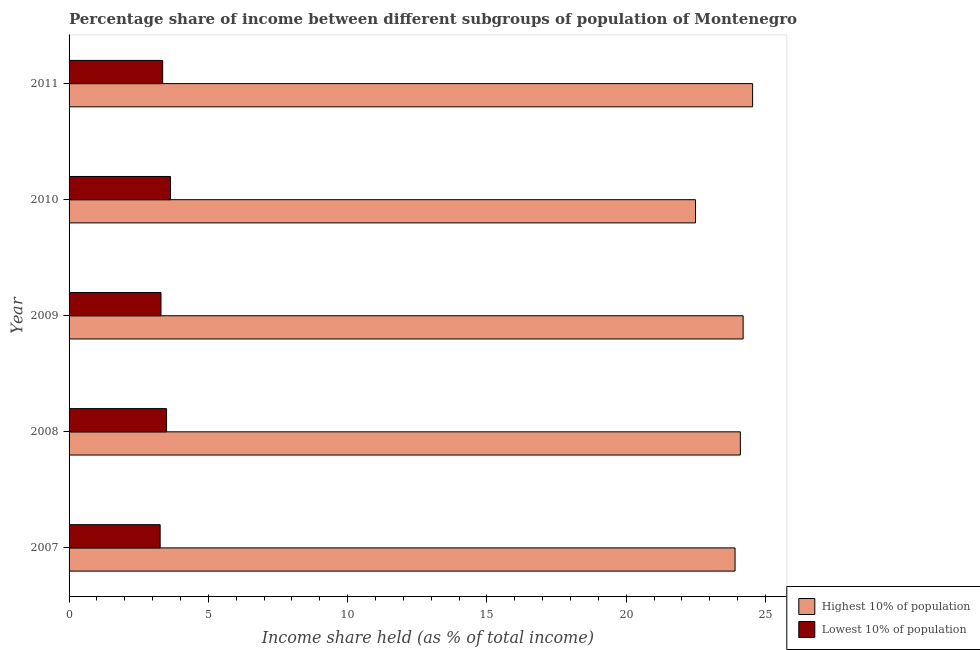How many groups of bars are there?
Provide a short and direct response. 5. Are the number of bars per tick equal to the number of legend labels?
Provide a succinct answer. Yes. Are the number of bars on each tick of the Y-axis equal?
Your answer should be very brief. Yes. How many bars are there on the 2nd tick from the top?
Keep it short and to the point. 2. In how many cases, is the number of bars for a given year not equal to the number of legend labels?
Give a very brief answer. 0. What is the income share held by highest 10% of the population in 2009?
Offer a terse response. 24.2. Across all years, what is the maximum income share held by lowest 10% of the population?
Make the answer very short. 3.64. Across all years, what is the minimum income share held by highest 10% of the population?
Ensure brevity in your answer.  22.49. In which year was the income share held by lowest 10% of the population maximum?
Provide a succinct answer. 2010. In which year was the income share held by highest 10% of the population minimum?
Your answer should be very brief. 2010. What is the total income share held by lowest 10% of the population in the graph?
Offer a terse response. 17.07. What is the difference between the income share held by highest 10% of the population in 2007 and that in 2011?
Your answer should be compact. -0.63. What is the difference between the income share held by highest 10% of the population in 2009 and the income share held by lowest 10% of the population in 2008?
Offer a terse response. 20.7. What is the average income share held by highest 10% of the population per year?
Provide a short and direct response. 23.85. In the year 2011, what is the difference between the income share held by highest 10% of the population and income share held by lowest 10% of the population?
Offer a terse response. 21.18. What is the ratio of the income share held by highest 10% of the population in 2007 to that in 2011?
Provide a short and direct response. 0.97. Is the difference between the income share held by highest 10% of the population in 2007 and 2011 greater than the difference between the income share held by lowest 10% of the population in 2007 and 2011?
Provide a short and direct response. No. What is the difference between the highest and the second highest income share held by highest 10% of the population?
Give a very brief answer. 0.34. What is the difference between the highest and the lowest income share held by lowest 10% of the population?
Provide a succinct answer. 0.37. In how many years, is the income share held by lowest 10% of the population greater than the average income share held by lowest 10% of the population taken over all years?
Provide a short and direct response. 2. Is the sum of the income share held by lowest 10% of the population in 2008 and 2011 greater than the maximum income share held by highest 10% of the population across all years?
Provide a succinct answer. No. What does the 2nd bar from the top in 2010 represents?
Your answer should be compact. Highest 10% of population. What does the 1st bar from the bottom in 2010 represents?
Make the answer very short. Highest 10% of population. How many bars are there?
Make the answer very short. 10. Are the values on the major ticks of X-axis written in scientific E-notation?
Your answer should be very brief. No. How many legend labels are there?
Keep it short and to the point. 2. What is the title of the graph?
Give a very brief answer. Percentage share of income between different subgroups of population of Montenegro. Does "Imports" appear as one of the legend labels in the graph?
Provide a succinct answer. No. What is the label or title of the X-axis?
Provide a succinct answer. Income share held (as % of total income). What is the label or title of the Y-axis?
Provide a short and direct response. Year. What is the Income share held (as % of total income) of Highest 10% of population in 2007?
Your response must be concise. 23.91. What is the Income share held (as % of total income) of Lowest 10% of population in 2007?
Your response must be concise. 3.27. What is the Income share held (as % of total income) of Highest 10% of population in 2008?
Offer a terse response. 24.1. What is the Income share held (as % of total income) of Highest 10% of population in 2009?
Offer a terse response. 24.2. What is the Income share held (as % of total income) in Highest 10% of population in 2010?
Provide a succinct answer. 22.49. What is the Income share held (as % of total income) in Lowest 10% of population in 2010?
Provide a short and direct response. 3.64. What is the Income share held (as % of total income) of Highest 10% of population in 2011?
Your response must be concise. 24.54. What is the Income share held (as % of total income) of Lowest 10% of population in 2011?
Ensure brevity in your answer.  3.36. Across all years, what is the maximum Income share held (as % of total income) of Highest 10% of population?
Keep it short and to the point. 24.54. Across all years, what is the maximum Income share held (as % of total income) of Lowest 10% of population?
Your answer should be compact. 3.64. Across all years, what is the minimum Income share held (as % of total income) in Highest 10% of population?
Your answer should be compact. 22.49. Across all years, what is the minimum Income share held (as % of total income) in Lowest 10% of population?
Make the answer very short. 3.27. What is the total Income share held (as % of total income) in Highest 10% of population in the graph?
Make the answer very short. 119.24. What is the total Income share held (as % of total income) of Lowest 10% of population in the graph?
Your response must be concise. 17.07. What is the difference between the Income share held (as % of total income) in Highest 10% of population in 2007 and that in 2008?
Offer a terse response. -0.19. What is the difference between the Income share held (as % of total income) of Lowest 10% of population in 2007 and that in 2008?
Offer a very short reply. -0.23. What is the difference between the Income share held (as % of total income) in Highest 10% of population in 2007 and that in 2009?
Your answer should be compact. -0.29. What is the difference between the Income share held (as % of total income) in Lowest 10% of population in 2007 and that in 2009?
Your response must be concise. -0.03. What is the difference between the Income share held (as % of total income) of Highest 10% of population in 2007 and that in 2010?
Make the answer very short. 1.42. What is the difference between the Income share held (as % of total income) in Lowest 10% of population in 2007 and that in 2010?
Make the answer very short. -0.37. What is the difference between the Income share held (as % of total income) in Highest 10% of population in 2007 and that in 2011?
Your response must be concise. -0.63. What is the difference between the Income share held (as % of total income) in Lowest 10% of population in 2007 and that in 2011?
Your answer should be compact. -0.09. What is the difference between the Income share held (as % of total income) in Highest 10% of population in 2008 and that in 2009?
Make the answer very short. -0.1. What is the difference between the Income share held (as % of total income) in Lowest 10% of population in 2008 and that in 2009?
Offer a terse response. 0.2. What is the difference between the Income share held (as % of total income) of Highest 10% of population in 2008 and that in 2010?
Provide a succinct answer. 1.61. What is the difference between the Income share held (as % of total income) in Lowest 10% of population in 2008 and that in 2010?
Provide a succinct answer. -0.14. What is the difference between the Income share held (as % of total income) in Highest 10% of population in 2008 and that in 2011?
Your response must be concise. -0.44. What is the difference between the Income share held (as % of total income) of Lowest 10% of population in 2008 and that in 2011?
Give a very brief answer. 0.14. What is the difference between the Income share held (as % of total income) in Highest 10% of population in 2009 and that in 2010?
Offer a very short reply. 1.71. What is the difference between the Income share held (as % of total income) in Lowest 10% of population in 2009 and that in 2010?
Ensure brevity in your answer.  -0.34. What is the difference between the Income share held (as % of total income) in Highest 10% of population in 2009 and that in 2011?
Offer a very short reply. -0.34. What is the difference between the Income share held (as % of total income) in Lowest 10% of population in 2009 and that in 2011?
Make the answer very short. -0.06. What is the difference between the Income share held (as % of total income) of Highest 10% of population in 2010 and that in 2011?
Keep it short and to the point. -2.05. What is the difference between the Income share held (as % of total income) of Lowest 10% of population in 2010 and that in 2011?
Your answer should be very brief. 0.28. What is the difference between the Income share held (as % of total income) of Highest 10% of population in 2007 and the Income share held (as % of total income) of Lowest 10% of population in 2008?
Your response must be concise. 20.41. What is the difference between the Income share held (as % of total income) of Highest 10% of population in 2007 and the Income share held (as % of total income) of Lowest 10% of population in 2009?
Keep it short and to the point. 20.61. What is the difference between the Income share held (as % of total income) in Highest 10% of population in 2007 and the Income share held (as % of total income) in Lowest 10% of population in 2010?
Keep it short and to the point. 20.27. What is the difference between the Income share held (as % of total income) of Highest 10% of population in 2007 and the Income share held (as % of total income) of Lowest 10% of population in 2011?
Offer a very short reply. 20.55. What is the difference between the Income share held (as % of total income) in Highest 10% of population in 2008 and the Income share held (as % of total income) in Lowest 10% of population in 2009?
Offer a terse response. 20.8. What is the difference between the Income share held (as % of total income) of Highest 10% of population in 2008 and the Income share held (as % of total income) of Lowest 10% of population in 2010?
Give a very brief answer. 20.46. What is the difference between the Income share held (as % of total income) of Highest 10% of population in 2008 and the Income share held (as % of total income) of Lowest 10% of population in 2011?
Offer a terse response. 20.74. What is the difference between the Income share held (as % of total income) of Highest 10% of population in 2009 and the Income share held (as % of total income) of Lowest 10% of population in 2010?
Your answer should be very brief. 20.56. What is the difference between the Income share held (as % of total income) in Highest 10% of population in 2009 and the Income share held (as % of total income) in Lowest 10% of population in 2011?
Ensure brevity in your answer.  20.84. What is the difference between the Income share held (as % of total income) in Highest 10% of population in 2010 and the Income share held (as % of total income) in Lowest 10% of population in 2011?
Your response must be concise. 19.13. What is the average Income share held (as % of total income) of Highest 10% of population per year?
Provide a succinct answer. 23.85. What is the average Income share held (as % of total income) in Lowest 10% of population per year?
Offer a very short reply. 3.41. In the year 2007, what is the difference between the Income share held (as % of total income) in Highest 10% of population and Income share held (as % of total income) in Lowest 10% of population?
Provide a short and direct response. 20.64. In the year 2008, what is the difference between the Income share held (as % of total income) in Highest 10% of population and Income share held (as % of total income) in Lowest 10% of population?
Give a very brief answer. 20.6. In the year 2009, what is the difference between the Income share held (as % of total income) of Highest 10% of population and Income share held (as % of total income) of Lowest 10% of population?
Give a very brief answer. 20.9. In the year 2010, what is the difference between the Income share held (as % of total income) in Highest 10% of population and Income share held (as % of total income) in Lowest 10% of population?
Your response must be concise. 18.85. In the year 2011, what is the difference between the Income share held (as % of total income) in Highest 10% of population and Income share held (as % of total income) in Lowest 10% of population?
Offer a terse response. 21.18. What is the ratio of the Income share held (as % of total income) of Lowest 10% of population in 2007 to that in 2008?
Your answer should be compact. 0.93. What is the ratio of the Income share held (as % of total income) of Highest 10% of population in 2007 to that in 2009?
Your answer should be very brief. 0.99. What is the ratio of the Income share held (as % of total income) in Lowest 10% of population in 2007 to that in 2009?
Provide a short and direct response. 0.99. What is the ratio of the Income share held (as % of total income) in Highest 10% of population in 2007 to that in 2010?
Provide a short and direct response. 1.06. What is the ratio of the Income share held (as % of total income) in Lowest 10% of population in 2007 to that in 2010?
Your answer should be very brief. 0.9. What is the ratio of the Income share held (as % of total income) in Highest 10% of population in 2007 to that in 2011?
Your answer should be compact. 0.97. What is the ratio of the Income share held (as % of total income) in Lowest 10% of population in 2007 to that in 2011?
Offer a very short reply. 0.97. What is the ratio of the Income share held (as % of total income) of Highest 10% of population in 2008 to that in 2009?
Ensure brevity in your answer.  1. What is the ratio of the Income share held (as % of total income) in Lowest 10% of population in 2008 to that in 2009?
Make the answer very short. 1.06. What is the ratio of the Income share held (as % of total income) of Highest 10% of population in 2008 to that in 2010?
Offer a very short reply. 1.07. What is the ratio of the Income share held (as % of total income) of Lowest 10% of population in 2008 to that in 2010?
Give a very brief answer. 0.96. What is the ratio of the Income share held (as % of total income) of Highest 10% of population in 2008 to that in 2011?
Provide a succinct answer. 0.98. What is the ratio of the Income share held (as % of total income) in Lowest 10% of population in 2008 to that in 2011?
Provide a succinct answer. 1.04. What is the ratio of the Income share held (as % of total income) in Highest 10% of population in 2009 to that in 2010?
Make the answer very short. 1.08. What is the ratio of the Income share held (as % of total income) of Lowest 10% of population in 2009 to that in 2010?
Your answer should be compact. 0.91. What is the ratio of the Income share held (as % of total income) of Highest 10% of population in 2009 to that in 2011?
Your response must be concise. 0.99. What is the ratio of the Income share held (as % of total income) in Lowest 10% of population in 2009 to that in 2011?
Provide a short and direct response. 0.98. What is the ratio of the Income share held (as % of total income) in Highest 10% of population in 2010 to that in 2011?
Offer a very short reply. 0.92. What is the ratio of the Income share held (as % of total income) of Lowest 10% of population in 2010 to that in 2011?
Offer a terse response. 1.08. What is the difference between the highest and the second highest Income share held (as % of total income) of Highest 10% of population?
Your response must be concise. 0.34. What is the difference between the highest and the second highest Income share held (as % of total income) in Lowest 10% of population?
Make the answer very short. 0.14. What is the difference between the highest and the lowest Income share held (as % of total income) in Highest 10% of population?
Keep it short and to the point. 2.05. What is the difference between the highest and the lowest Income share held (as % of total income) of Lowest 10% of population?
Keep it short and to the point. 0.37. 